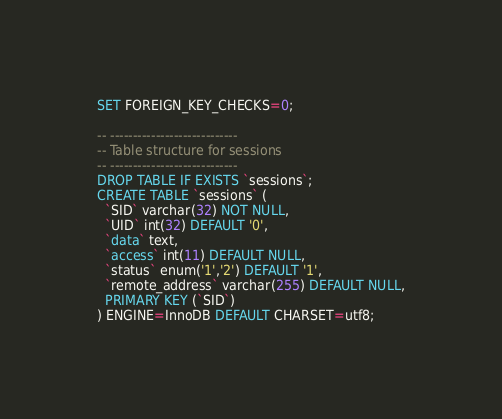<code> <loc_0><loc_0><loc_500><loc_500><_SQL_>SET FOREIGN_KEY_CHECKS=0;

-- ----------------------------
-- Table structure for sessions
-- ----------------------------
DROP TABLE IF EXISTS `sessions`;
CREATE TABLE `sessions` (
  `SID` varchar(32) NOT NULL,
  `UID` int(32) DEFAULT '0',
  `data` text,
  `access` int(11) DEFAULT NULL,
  `status` enum('1','2') DEFAULT '1',
  `remote_address` varchar(255) DEFAULT NULL,
  PRIMARY KEY (`SID`)
) ENGINE=InnoDB DEFAULT CHARSET=utf8;
</code> 